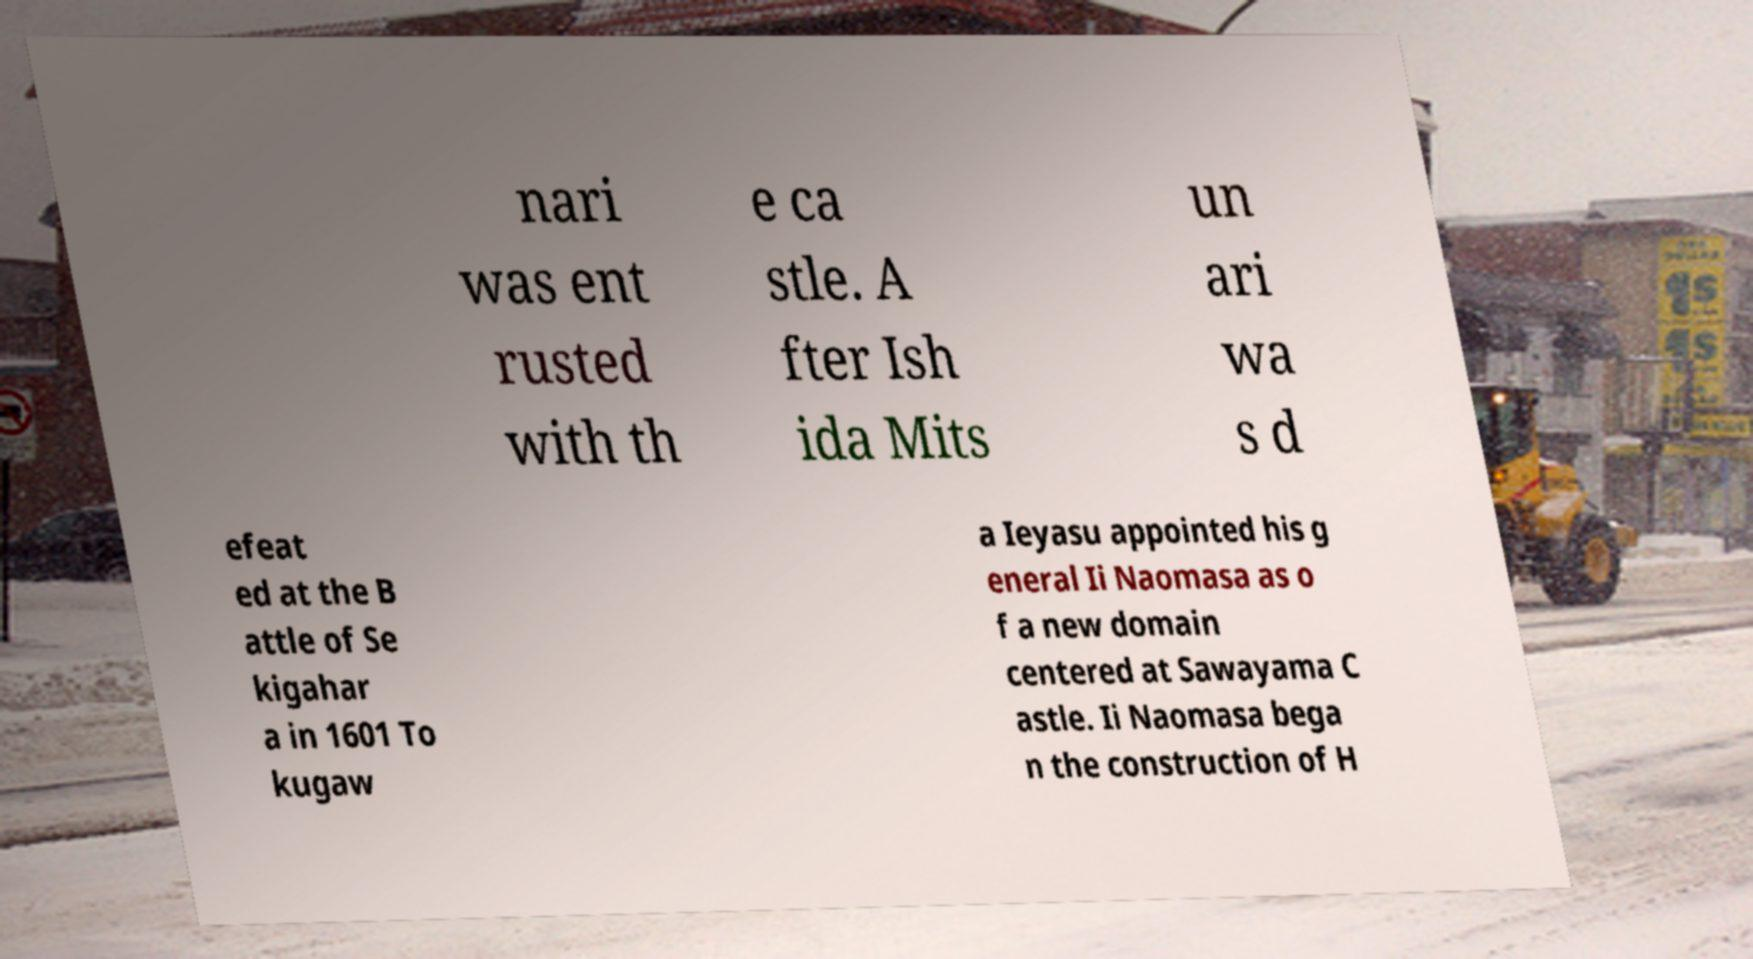For documentation purposes, I need the text within this image transcribed. Could you provide that? nari was ent rusted with th e ca stle. A fter Ish ida Mits un ari wa s d efeat ed at the B attle of Se kigahar a in 1601 To kugaw a Ieyasu appointed his g eneral Ii Naomasa as o f a new domain centered at Sawayama C astle. Ii Naomasa bega n the construction of H 